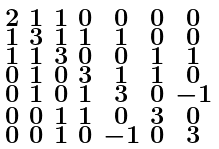<formula> <loc_0><loc_0><loc_500><loc_500>\begin{smallmatrix} 2 & 1 & 1 & 0 & 0 & 0 & 0 \\ 1 & 3 & 1 & 1 & 1 & 0 & 0 \\ 1 & 1 & 3 & 0 & 0 & 1 & 1 \\ 0 & 1 & 0 & 3 & 1 & 1 & 0 \\ 0 & 1 & 0 & 1 & 3 & 0 & - 1 \\ 0 & 0 & 1 & 1 & 0 & 3 & 0 \\ 0 & 0 & 1 & 0 & - 1 & 0 & 3 \end{smallmatrix}</formula> 